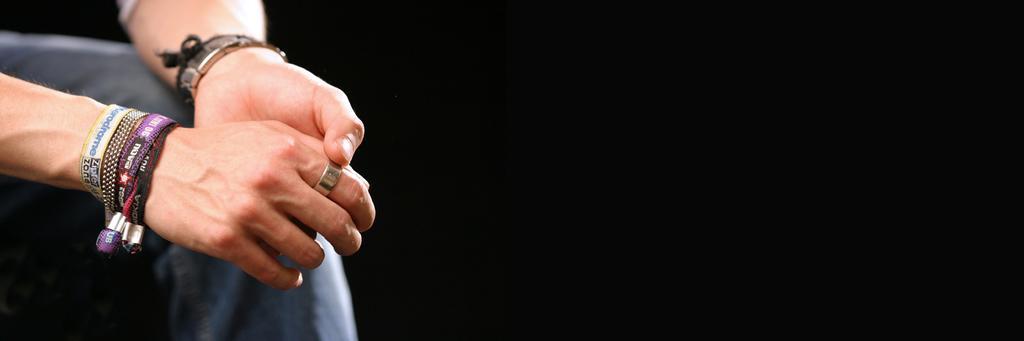Describe this image in one or two sentences. In the picture we can see a person hands with bands and a ring to the finger, under the hands we can see a leg. 